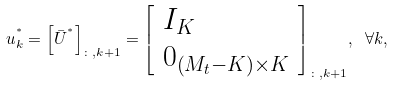<formula> <loc_0><loc_0><loc_500><loc_500>{ u } _ { k } ^ { ^ { * } } = { \left [ { \bar { U } } ^ { ^ { * } } \right ] _ { \colon , k + 1 } } = { \left [ \begin{array} { l } { { I } _ { K } } \\ { { 0 } _ { \left ( { { M _ { t } } - K } \right ) \times K } } \end{array} \right ] _ { \colon , k + 1 } } , \ \forall k ,</formula> 